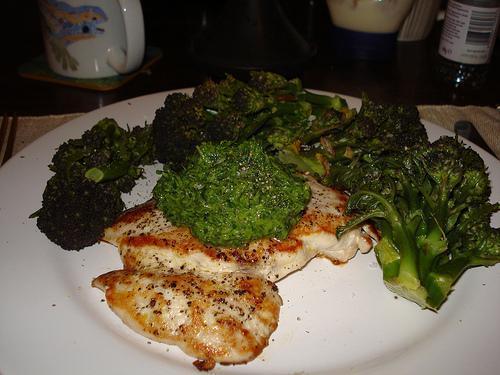How many plates of food are in the picture?
Give a very brief answer. 1. 